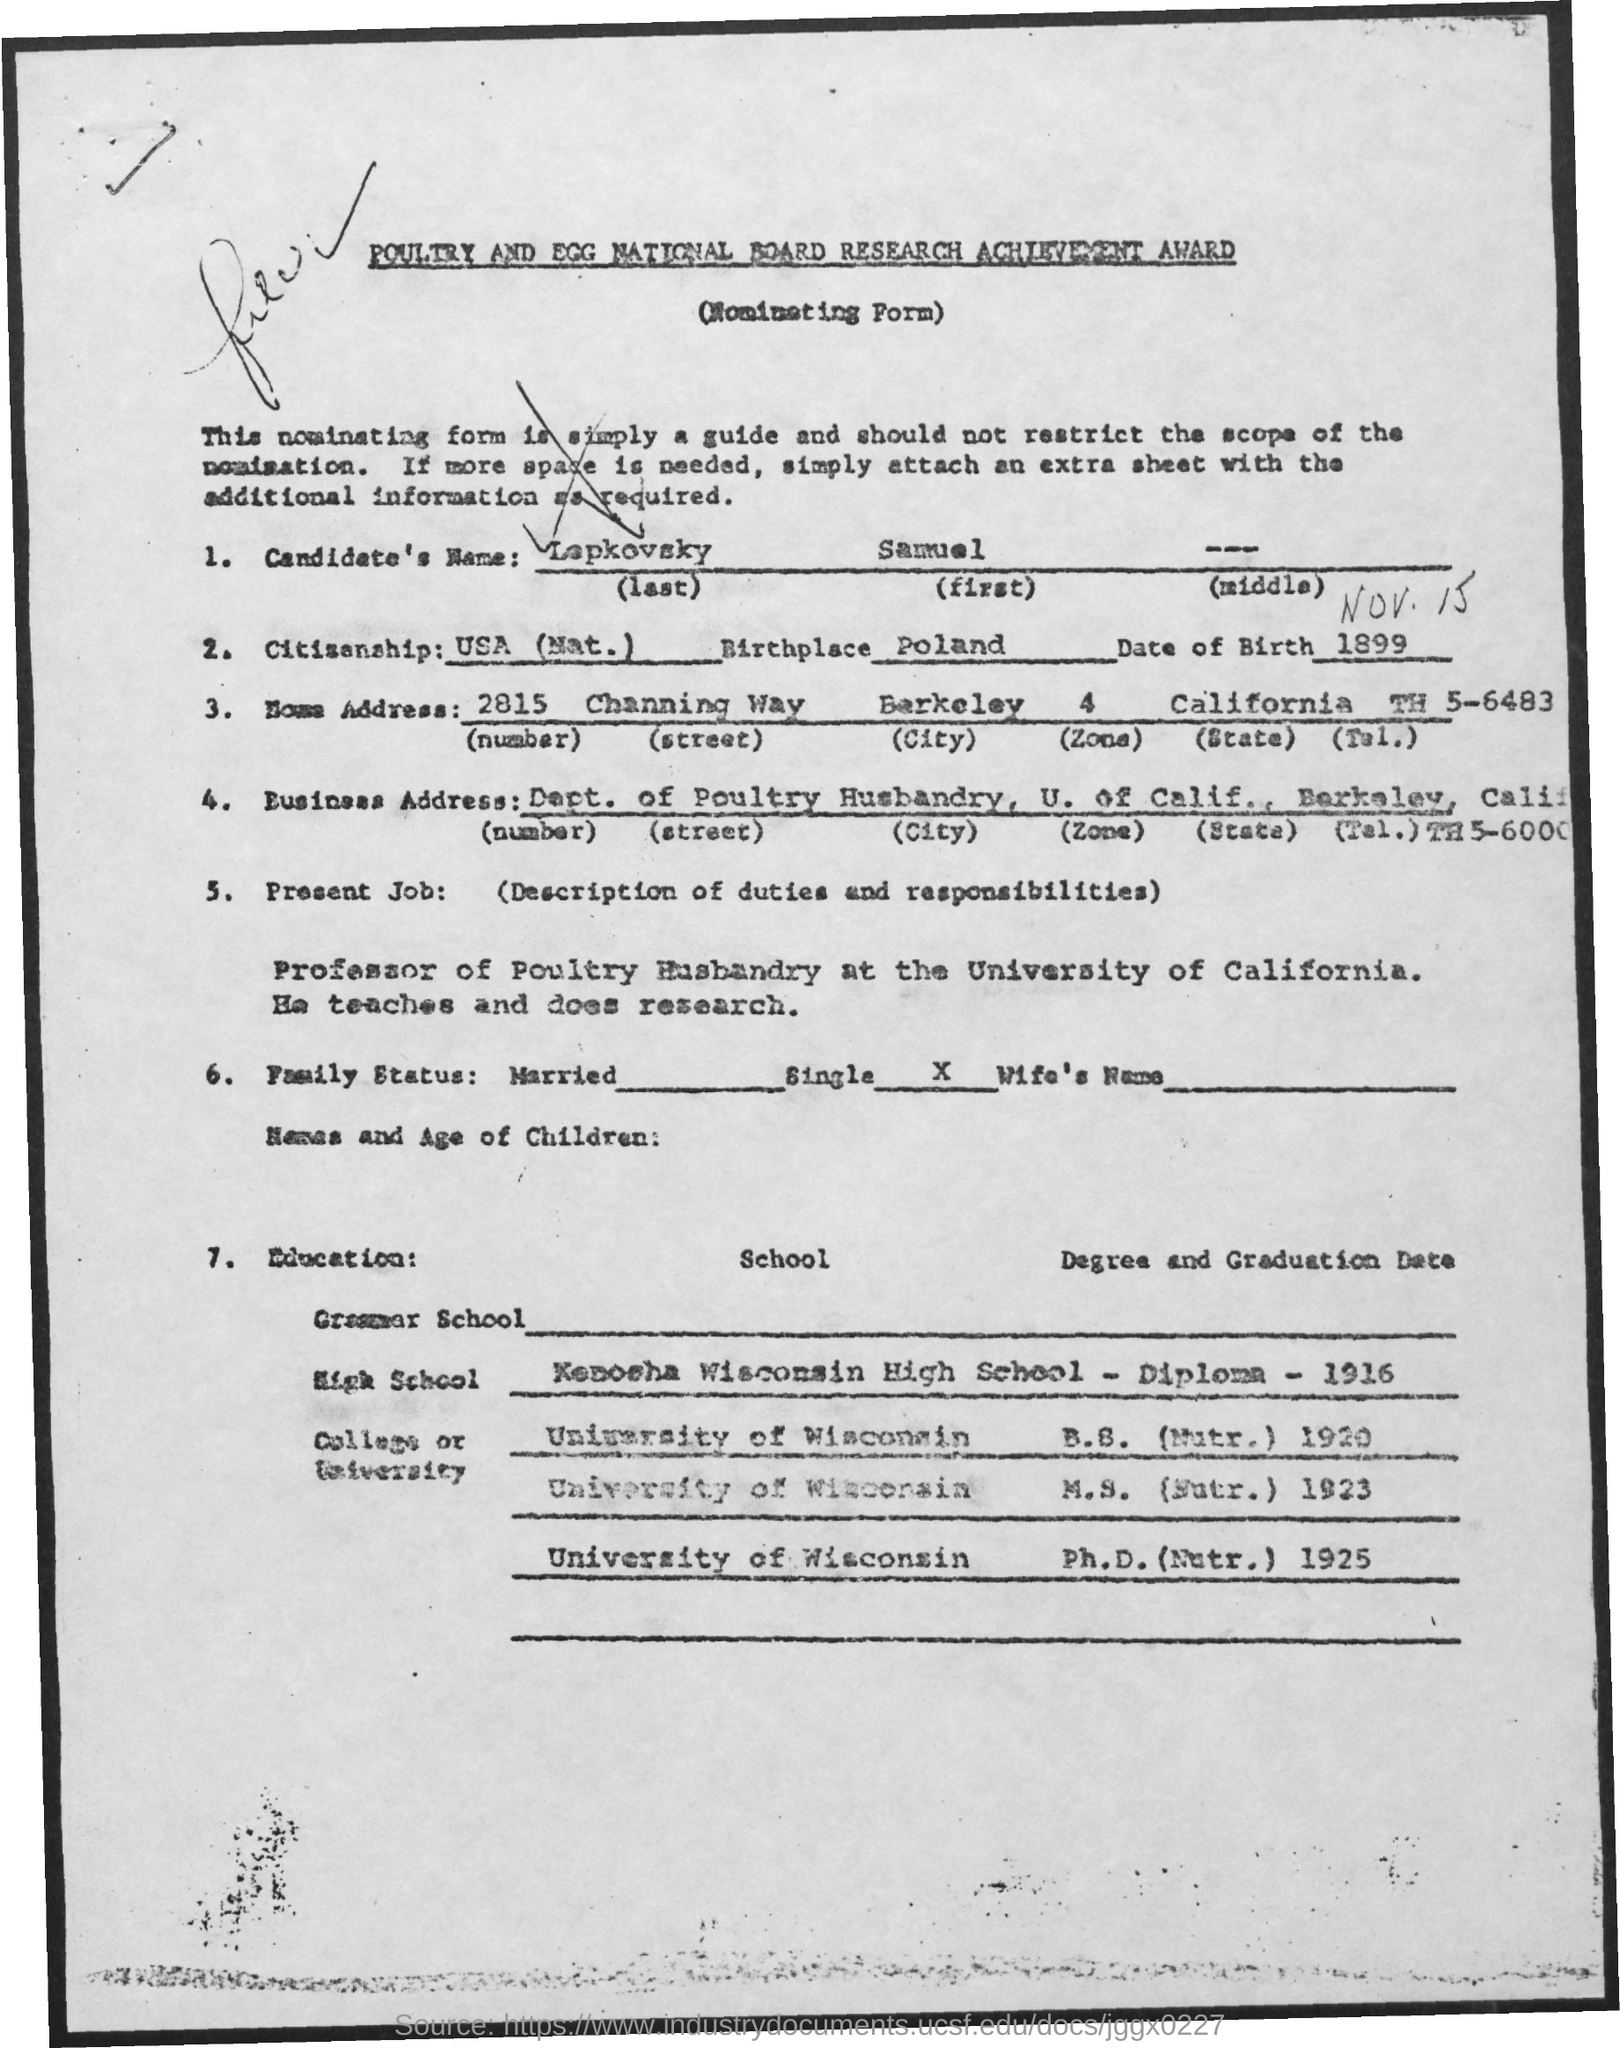What is the first name of the candidate mentioned in the form ?
Provide a succinct answer. Samuel. What is the name of the birth place mentioned in the form ?
Make the answer very short. Poland. 